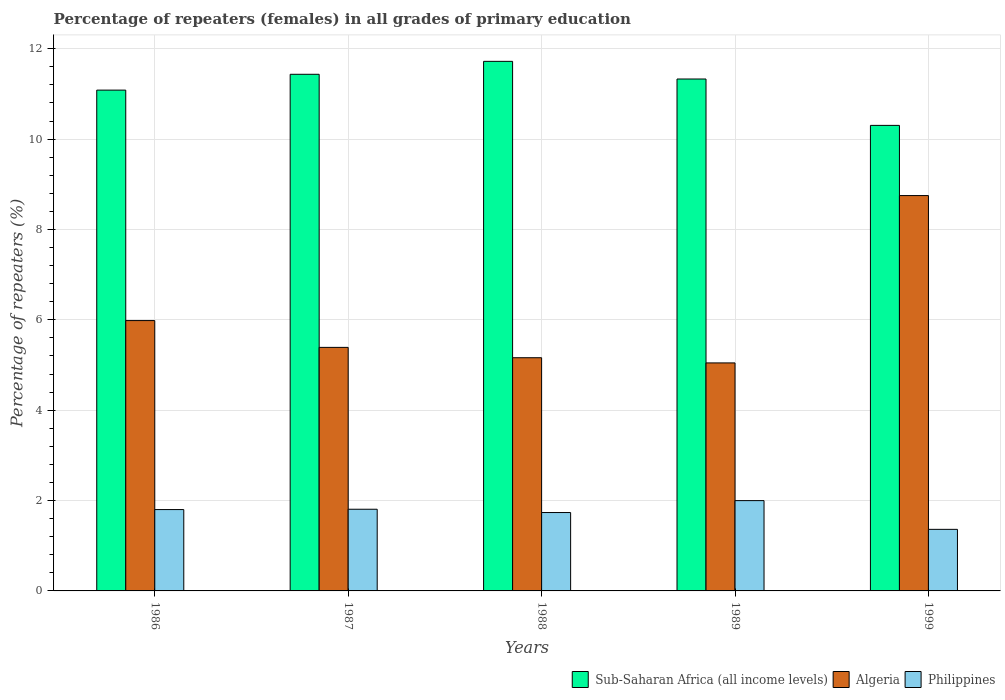How many different coloured bars are there?
Give a very brief answer. 3. How many bars are there on the 2nd tick from the right?
Your answer should be compact. 3. In how many cases, is the number of bars for a given year not equal to the number of legend labels?
Provide a short and direct response. 0. What is the percentage of repeaters (females) in Philippines in 1989?
Provide a short and direct response. 2. Across all years, what is the maximum percentage of repeaters (females) in Sub-Saharan Africa (all income levels)?
Make the answer very short. 11.72. Across all years, what is the minimum percentage of repeaters (females) in Philippines?
Your answer should be compact. 1.36. What is the total percentage of repeaters (females) in Sub-Saharan Africa (all income levels) in the graph?
Your response must be concise. 55.87. What is the difference between the percentage of repeaters (females) in Algeria in 1986 and that in 1989?
Ensure brevity in your answer.  0.94. What is the difference between the percentage of repeaters (females) in Algeria in 1988 and the percentage of repeaters (females) in Philippines in 1999?
Your answer should be very brief. 3.8. What is the average percentage of repeaters (females) in Algeria per year?
Your response must be concise. 6.07. In the year 1988, what is the difference between the percentage of repeaters (females) in Sub-Saharan Africa (all income levels) and percentage of repeaters (females) in Philippines?
Ensure brevity in your answer.  9.99. In how many years, is the percentage of repeaters (females) in Algeria greater than 2 %?
Give a very brief answer. 5. What is the ratio of the percentage of repeaters (females) in Algeria in 1986 to that in 1999?
Your response must be concise. 0.68. What is the difference between the highest and the second highest percentage of repeaters (females) in Philippines?
Provide a succinct answer. 0.19. What is the difference between the highest and the lowest percentage of repeaters (females) in Sub-Saharan Africa (all income levels)?
Provide a short and direct response. 1.42. In how many years, is the percentage of repeaters (females) in Algeria greater than the average percentage of repeaters (females) in Algeria taken over all years?
Offer a very short reply. 1. What does the 1st bar from the left in 1988 represents?
Offer a very short reply. Sub-Saharan Africa (all income levels). What does the 2nd bar from the right in 1986 represents?
Your answer should be very brief. Algeria. Is it the case that in every year, the sum of the percentage of repeaters (females) in Sub-Saharan Africa (all income levels) and percentage of repeaters (females) in Philippines is greater than the percentage of repeaters (females) in Algeria?
Your answer should be compact. Yes. Are all the bars in the graph horizontal?
Provide a succinct answer. No. Does the graph contain grids?
Provide a short and direct response. Yes. Where does the legend appear in the graph?
Offer a very short reply. Bottom right. What is the title of the graph?
Your answer should be compact. Percentage of repeaters (females) in all grades of primary education. What is the label or title of the Y-axis?
Ensure brevity in your answer.  Percentage of repeaters (%). What is the Percentage of repeaters (%) of Sub-Saharan Africa (all income levels) in 1986?
Make the answer very short. 11.08. What is the Percentage of repeaters (%) in Algeria in 1986?
Your answer should be very brief. 5.98. What is the Percentage of repeaters (%) of Philippines in 1986?
Your answer should be very brief. 1.8. What is the Percentage of repeaters (%) of Sub-Saharan Africa (all income levels) in 1987?
Provide a short and direct response. 11.43. What is the Percentage of repeaters (%) in Algeria in 1987?
Offer a very short reply. 5.39. What is the Percentage of repeaters (%) in Philippines in 1987?
Offer a terse response. 1.81. What is the Percentage of repeaters (%) of Sub-Saharan Africa (all income levels) in 1988?
Give a very brief answer. 11.72. What is the Percentage of repeaters (%) of Algeria in 1988?
Make the answer very short. 5.16. What is the Percentage of repeaters (%) of Philippines in 1988?
Your answer should be compact. 1.73. What is the Percentage of repeaters (%) in Sub-Saharan Africa (all income levels) in 1989?
Your answer should be compact. 11.33. What is the Percentage of repeaters (%) of Algeria in 1989?
Provide a short and direct response. 5.05. What is the Percentage of repeaters (%) in Philippines in 1989?
Offer a very short reply. 2. What is the Percentage of repeaters (%) of Sub-Saharan Africa (all income levels) in 1999?
Make the answer very short. 10.3. What is the Percentage of repeaters (%) in Algeria in 1999?
Provide a succinct answer. 8.75. What is the Percentage of repeaters (%) of Philippines in 1999?
Keep it short and to the point. 1.36. Across all years, what is the maximum Percentage of repeaters (%) in Sub-Saharan Africa (all income levels)?
Make the answer very short. 11.72. Across all years, what is the maximum Percentage of repeaters (%) in Algeria?
Keep it short and to the point. 8.75. Across all years, what is the maximum Percentage of repeaters (%) in Philippines?
Keep it short and to the point. 2. Across all years, what is the minimum Percentage of repeaters (%) of Sub-Saharan Africa (all income levels)?
Provide a succinct answer. 10.3. Across all years, what is the minimum Percentage of repeaters (%) in Algeria?
Ensure brevity in your answer.  5.05. Across all years, what is the minimum Percentage of repeaters (%) in Philippines?
Provide a short and direct response. 1.36. What is the total Percentage of repeaters (%) in Sub-Saharan Africa (all income levels) in the graph?
Offer a very short reply. 55.87. What is the total Percentage of repeaters (%) of Algeria in the graph?
Provide a short and direct response. 30.33. What is the total Percentage of repeaters (%) of Philippines in the graph?
Ensure brevity in your answer.  8.7. What is the difference between the Percentage of repeaters (%) of Sub-Saharan Africa (all income levels) in 1986 and that in 1987?
Your answer should be very brief. -0.35. What is the difference between the Percentage of repeaters (%) in Algeria in 1986 and that in 1987?
Make the answer very short. 0.59. What is the difference between the Percentage of repeaters (%) of Philippines in 1986 and that in 1987?
Your answer should be very brief. -0.01. What is the difference between the Percentage of repeaters (%) in Sub-Saharan Africa (all income levels) in 1986 and that in 1988?
Provide a short and direct response. -0.64. What is the difference between the Percentage of repeaters (%) in Algeria in 1986 and that in 1988?
Your answer should be very brief. 0.82. What is the difference between the Percentage of repeaters (%) in Philippines in 1986 and that in 1988?
Offer a terse response. 0.07. What is the difference between the Percentage of repeaters (%) of Sub-Saharan Africa (all income levels) in 1986 and that in 1989?
Your response must be concise. -0.25. What is the difference between the Percentage of repeaters (%) of Algeria in 1986 and that in 1989?
Your answer should be very brief. 0.94. What is the difference between the Percentage of repeaters (%) in Philippines in 1986 and that in 1989?
Provide a succinct answer. -0.2. What is the difference between the Percentage of repeaters (%) in Sub-Saharan Africa (all income levels) in 1986 and that in 1999?
Make the answer very short. 0.78. What is the difference between the Percentage of repeaters (%) of Algeria in 1986 and that in 1999?
Offer a terse response. -2.77. What is the difference between the Percentage of repeaters (%) in Philippines in 1986 and that in 1999?
Provide a succinct answer. 0.44. What is the difference between the Percentage of repeaters (%) in Sub-Saharan Africa (all income levels) in 1987 and that in 1988?
Make the answer very short. -0.29. What is the difference between the Percentage of repeaters (%) of Algeria in 1987 and that in 1988?
Keep it short and to the point. 0.23. What is the difference between the Percentage of repeaters (%) in Philippines in 1987 and that in 1988?
Make the answer very short. 0.07. What is the difference between the Percentage of repeaters (%) in Sub-Saharan Africa (all income levels) in 1987 and that in 1989?
Offer a terse response. 0.1. What is the difference between the Percentage of repeaters (%) in Algeria in 1987 and that in 1989?
Your answer should be very brief. 0.34. What is the difference between the Percentage of repeaters (%) of Philippines in 1987 and that in 1989?
Ensure brevity in your answer.  -0.19. What is the difference between the Percentage of repeaters (%) of Sub-Saharan Africa (all income levels) in 1987 and that in 1999?
Make the answer very short. 1.13. What is the difference between the Percentage of repeaters (%) in Algeria in 1987 and that in 1999?
Provide a succinct answer. -3.36. What is the difference between the Percentage of repeaters (%) in Philippines in 1987 and that in 1999?
Give a very brief answer. 0.44. What is the difference between the Percentage of repeaters (%) in Sub-Saharan Africa (all income levels) in 1988 and that in 1989?
Give a very brief answer. 0.39. What is the difference between the Percentage of repeaters (%) in Algeria in 1988 and that in 1989?
Ensure brevity in your answer.  0.11. What is the difference between the Percentage of repeaters (%) of Philippines in 1988 and that in 1989?
Your response must be concise. -0.26. What is the difference between the Percentage of repeaters (%) of Sub-Saharan Africa (all income levels) in 1988 and that in 1999?
Make the answer very short. 1.42. What is the difference between the Percentage of repeaters (%) in Algeria in 1988 and that in 1999?
Provide a short and direct response. -3.59. What is the difference between the Percentage of repeaters (%) in Philippines in 1988 and that in 1999?
Provide a short and direct response. 0.37. What is the difference between the Percentage of repeaters (%) of Sub-Saharan Africa (all income levels) in 1989 and that in 1999?
Your answer should be very brief. 1.03. What is the difference between the Percentage of repeaters (%) in Algeria in 1989 and that in 1999?
Offer a very short reply. -3.7. What is the difference between the Percentage of repeaters (%) in Philippines in 1989 and that in 1999?
Ensure brevity in your answer.  0.64. What is the difference between the Percentage of repeaters (%) in Sub-Saharan Africa (all income levels) in 1986 and the Percentage of repeaters (%) in Algeria in 1987?
Provide a succinct answer. 5.69. What is the difference between the Percentage of repeaters (%) of Sub-Saharan Africa (all income levels) in 1986 and the Percentage of repeaters (%) of Philippines in 1987?
Your answer should be very brief. 9.28. What is the difference between the Percentage of repeaters (%) of Algeria in 1986 and the Percentage of repeaters (%) of Philippines in 1987?
Give a very brief answer. 4.18. What is the difference between the Percentage of repeaters (%) of Sub-Saharan Africa (all income levels) in 1986 and the Percentage of repeaters (%) of Algeria in 1988?
Your answer should be very brief. 5.92. What is the difference between the Percentage of repeaters (%) of Sub-Saharan Africa (all income levels) in 1986 and the Percentage of repeaters (%) of Philippines in 1988?
Offer a very short reply. 9.35. What is the difference between the Percentage of repeaters (%) of Algeria in 1986 and the Percentage of repeaters (%) of Philippines in 1988?
Provide a succinct answer. 4.25. What is the difference between the Percentage of repeaters (%) of Sub-Saharan Africa (all income levels) in 1986 and the Percentage of repeaters (%) of Algeria in 1989?
Offer a terse response. 6.04. What is the difference between the Percentage of repeaters (%) of Sub-Saharan Africa (all income levels) in 1986 and the Percentage of repeaters (%) of Philippines in 1989?
Your answer should be very brief. 9.08. What is the difference between the Percentage of repeaters (%) in Algeria in 1986 and the Percentage of repeaters (%) in Philippines in 1989?
Offer a very short reply. 3.98. What is the difference between the Percentage of repeaters (%) in Sub-Saharan Africa (all income levels) in 1986 and the Percentage of repeaters (%) in Algeria in 1999?
Make the answer very short. 2.33. What is the difference between the Percentage of repeaters (%) in Sub-Saharan Africa (all income levels) in 1986 and the Percentage of repeaters (%) in Philippines in 1999?
Make the answer very short. 9.72. What is the difference between the Percentage of repeaters (%) in Algeria in 1986 and the Percentage of repeaters (%) in Philippines in 1999?
Your answer should be very brief. 4.62. What is the difference between the Percentage of repeaters (%) in Sub-Saharan Africa (all income levels) in 1987 and the Percentage of repeaters (%) in Algeria in 1988?
Offer a terse response. 6.27. What is the difference between the Percentage of repeaters (%) in Sub-Saharan Africa (all income levels) in 1987 and the Percentage of repeaters (%) in Philippines in 1988?
Give a very brief answer. 9.7. What is the difference between the Percentage of repeaters (%) of Algeria in 1987 and the Percentage of repeaters (%) of Philippines in 1988?
Give a very brief answer. 3.66. What is the difference between the Percentage of repeaters (%) of Sub-Saharan Africa (all income levels) in 1987 and the Percentage of repeaters (%) of Algeria in 1989?
Provide a short and direct response. 6.39. What is the difference between the Percentage of repeaters (%) in Sub-Saharan Africa (all income levels) in 1987 and the Percentage of repeaters (%) in Philippines in 1989?
Your answer should be very brief. 9.44. What is the difference between the Percentage of repeaters (%) in Algeria in 1987 and the Percentage of repeaters (%) in Philippines in 1989?
Your answer should be very brief. 3.39. What is the difference between the Percentage of repeaters (%) in Sub-Saharan Africa (all income levels) in 1987 and the Percentage of repeaters (%) in Algeria in 1999?
Keep it short and to the point. 2.68. What is the difference between the Percentage of repeaters (%) in Sub-Saharan Africa (all income levels) in 1987 and the Percentage of repeaters (%) in Philippines in 1999?
Your answer should be very brief. 10.07. What is the difference between the Percentage of repeaters (%) of Algeria in 1987 and the Percentage of repeaters (%) of Philippines in 1999?
Your response must be concise. 4.03. What is the difference between the Percentage of repeaters (%) in Sub-Saharan Africa (all income levels) in 1988 and the Percentage of repeaters (%) in Algeria in 1989?
Your answer should be compact. 6.67. What is the difference between the Percentage of repeaters (%) in Sub-Saharan Africa (all income levels) in 1988 and the Percentage of repeaters (%) in Philippines in 1989?
Provide a short and direct response. 9.72. What is the difference between the Percentage of repeaters (%) of Algeria in 1988 and the Percentage of repeaters (%) of Philippines in 1989?
Give a very brief answer. 3.16. What is the difference between the Percentage of repeaters (%) in Sub-Saharan Africa (all income levels) in 1988 and the Percentage of repeaters (%) in Algeria in 1999?
Provide a succinct answer. 2.97. What is the difference between the Percentage of repeaters (%) of Sub-Saharan Africa (all income levels) in 1988 and the Percentage of repeaters (%) of Philippines in 1999?
Keep it short and to the point. 10.36. What is the difference between the Percentage of repeaters (%) in Algeria in 1988 and the Percentage of repeaters (%) in Philippines in 1999?
Your answer should be compact. 3.8. What is the difference between the Percentage of repeaters (%) in Sub-Saharan Africa (all income levels) in 1989 and the Percentage of repeaters (%) in Algeria in 1999?
Give a very brief answer. 2.58. What is the difference between the Percentage of repeaters (%) in Sub-Saharan Africa (all income levels) in 1989 and the Percentage of repeaters (%) in Philippines in 1999?
Your answer should be very brief. 9.97. What is the difference between the Percentage of repeaters (%) in Algeria in 1989 and the Percentage of repeaters (%) in Philippines in 1999?
Provide a short and direct response. 3.68. What is the average Percentage of repeaters (%) of Sub-Saharan Africa (all income levels) per year?
Offer a very short reply. 11.17. What is the average Percentage of repeaters (%) of Algeria per year?
Offer a very short reply. 6.07. What is the average Percentage of repeaters (%) in Philippines per year?
Your response must be concise. 1.74. In the year 1986, what is the difference between the Percentage of repeaters (%) in Sub-Saharan Africa (all income levels) and Percentage of repeaters (%) in Algeria?
Provide a succinct answer. 5.1. In the year 1986, what is the difference between the Percentage of repeaters (%) in Sub-Saharan Africa (all income levels) and Percentage of repeaters (%) in Philippines?
Provide a short and direct response. 9.28. In the year 1986, what is the difference between the Percentage of repeaters (%) of Algeria and Percentage of repeaters (%) of Philippines?
Make the answer very short. 4.18. In the year 1987, what is the difference between the Percentage of repeaters (%) of Sub-Saharan Africa (all income levels) and Percentage of repeaters (%) of Algeria?
Provide a short and direct response. 6.04. In the year 1987, what is the difference between the Percentage of repeaters (%) of Sub-Saharan Africa (all income levels) and Percentage of repeaters (%) of Philippines?
Offer a very short reply. 9.63. In the year 1987, what is the difference between the Percentage of repeaters (%) in Algeria and Percentage of repeaters (%) in Philippines?
Give a very brief answer. 3.58. In the year 1988, what is the difference between the Percentage of repeaters (%) in Sub-Saharan Africa (all income levels) and Percentage of repeaters (%) in Algeria?
Ensure brevity in your answer.  6.56. In the year 1988, what is the difference between the Percentage of repeaters (%) in Sub-Saharan Africa (all income levels) and Percentage of repeaters (%) in Philippines?
Provide a short and direct response. 9.99. In the year 1988, what is the difference between the Percentage of repeaters (%) in Algeria and Percentage of repeaters (%) in Philippines?
Offer a very short reply. 3.43. In the year 1989, what is the difference between the Percentage of repeaters (%) in Sub-Saharan Africa (all income levels) and Percentage of repeaters (%) in Algeria?
Your answer should be compact. 6.28. In the year 1989, what is the difference between the Percentage of repeaters (%) of Sub-Saharan Africa (all income levels) and Percentage of repeaters (%) of Philippines?
Your response must be concise. 9.33. In the year 1989, what is the difference between the Percentage of repeaters (%) of Algeria and Percentage of repeaters (%) of Philippines?
Give a very brief answer. 3.05. In the year 1999, what is the difference between the Percentage of repeaters (%) in Sub-Saharan Africa (all income levels) and Percentage of repeaters (%) in Algeria?
Provide a short and direct response. 1.55. In the year 1999, what is the difference between the Percentage of repeaters (%) in Sub-Saharan Africa (all income levels) and Percentage of repeaters (%) in Philippines?
Your answer should be very brief. 8.94. In the year 1999, what is the difference between the Percentage of repeaters (%) in Algeria and Percentage of repeaters (%) in Philippines?
Keep it short and to the point. 7.39. What is the ratio of the Percentage of repeaters (%) in Sub-Saharan Africa (all income levels) in 1986 to that in 1987?
Provide a short and direct response. 0.97. What is the ratio of the Percentage of repeaters (%) of Algeria in 1986 to that in 1987?
Offer a terse response. 1.11. What is the ratio of the Percentage of repeaters (%) in Sub-Saharan Africa (all income levels) in 1986 to that in 1988?
Your answer should be very brief. 0.95. What is the ratio of the Percentage of repeaters (%) of Algeria in 1986 to that in 1988?
Your answer should be compact. 1.16. What is the ratio of the Percentage of repeaters (%) in Philippines in 1986 to that in 1988?
Give a very brief answer. 1.04. What is the ratio of the Percentage of repeaters (%) of Sub-Saharan Africa (all income levels) in 1986 to that in 1989?
Offer a very short reply. 0.98. What is the ratio of the Percentage of repeaters (%) in Algeria in 1986 to that in 1989?
Your answer should be compact. 1.19. What is the ratio of the Percentage of repeaters (%) of Philippines in 1986 to that in 1989?
Provide a short and direct response. 0.9. What is the ratio of the Percentage of repeaters (%) of Sub-Saharan Africa (all income levels) in 1986 to that in 1999?
Your response must be concise. 1.08. What is the ratio of the Percentage of repeaters (%) of Algeria in 1986 to that in 1999?
Your answer should be compact. 0.68. What is the ratio of the Percentage of repeaters (%) in Philippines in 1986 to that in 1999?
Your response must be concise. 1.32. What is the ratio of the Percentage of repeaters (%) in Sub-Saharan Africa (all income levels) in 1987 to that in 1988?
Offer a very short reply. 0.98. What is the ratio of the Percentage of repeaters (%) in Algeria in 1987 to that in 1988?
Provide a succinct answer. 1.04. What is the ratio of the Percentage of repeaters (%) of Philippines in 1987 to that in 1988?
Provide a succinct answer. 1.04. What is the ratio of the Percentage of repeaters (%) in Sub-Saharan Africa (all income levels) in 1987 to that in 1989?
Your answer should be compact. 1.01. What is the ratio of the Percentage of repeaters (%) of Algeria in 1987 to that in 1989?
Make the answer very short. 1.07. What is the ratio of the Percentage of repeaters (%) in Philippines in 1987 to that in 1989?
Offer a terse response. 0.9. What is the ratio of the Percentage of repeaters (%) in Sub-Saharan Africa (all income levels) in 1987 to that in 1999?
Provide a succinct answer. 1.11. What is the ratio of the Percentage of repeaters (%) in Algeria in 1987 to that in 1999?
Your answer should be compact. 0.62. What is the ratio of the Percentage of repeaters (%) of Philippines in 1987 to that in 1999?
Provide a succinct answer. 1.33. What is the ratio of the Percentage of repeaters (%) in Sub-Saharan Africa (all income levels) in 1988 to that in 1989?
Ensure brevity in your answer.  1.03. What is the ratio of the Percentage of repeaters (%) in Algeria in 1988 to that in 1989?
Keep it short and to the point. 1.02. What is the ratio of the Percentage of repeaters (%) of Philippines in 1988 to that in 1989?
Provide a short and direct response. 0.87. What is the ratio of the Percentage of repeaters (%) in Sub-Saharan Africa (all income levels) in 1988 to that in 1999?
Keep it short and to the point. 1.14. What is the ratio of the Percentage of repeaters (%) in Algeria in 1988 to that in 1999?
Offer a very short reply. 0.59. What is the ratio of the Percentage of repeaters (%) in Philippines in 1988 to that in 1999?
Offer a very short reply. 1.27. What is the ratio of the Percentage of repeaters (%) in Sub-Saharan Africa (all income levels) in 1989 to that in 1999?
Keep it short and to the point. 1.1. What is the ratio of the Percentage of repeaters (%) of Algeria in 1989 to that in 1999?
Give a very brief answer. 0.58. What is the ratio of the Percentage of repeaters (%) of Philippines in 1989 to that in 1999?
Give a very brief answer. 1.47. What is the difference between the highest and the second highest Percentage of repeaters (%) of Sub-Saharan Africa (all income levels)?
Ensure brevity in your answer.  0.29. What is the difference between the highest and the second highest Percentage of repeaters (%) of Algeria?
Your answer should be very brief. 2.77. What is the difference between the highest and the second highest Percentage of repeaters (%) in Philippines?
Your answer should be compact. 0.19. What is the difference between the highest and the lowest Percentage of repeaters (%) of Sub-Saharan Africa (all income levels)?
Give a very brief answer. 1.42. What is the difference between the highest and the lowest Percentage of repeaters (%) of Algeria?
Your response must be concise. 3.7. What is the difference between the highest and the lowest Percentage of repeaters (%) of Philippines?
Offer a terse response. 0.64. 